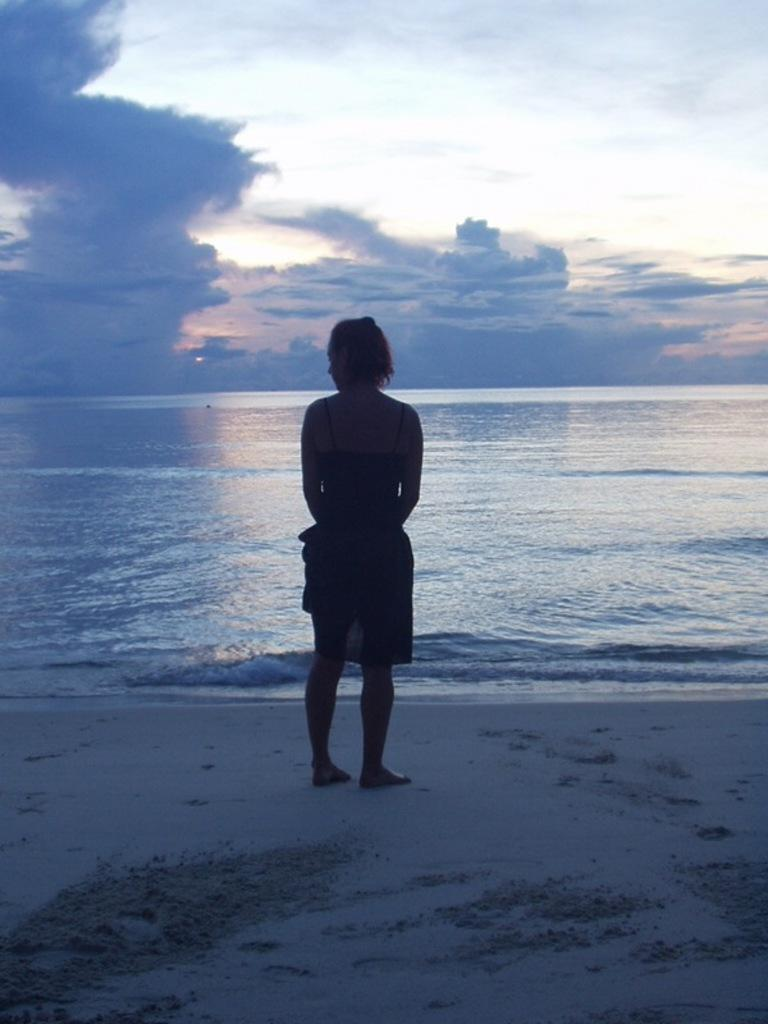What is the main subject of the image? There is a person standing in the image. What is the person standing on? The person is standing on the ground. What can be seen in the background of the image? Water and the sky are visible in the background of the image. What is the condition of the sky in the image? Clouds are present in the sky. What type of butter is being used by the person in the image? There is no butter present in the image, and the person is not using any butter. 